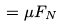<formula> <loc_0><loc_0><loc_500><loc_500>= \mu F _ { N }</formula> 